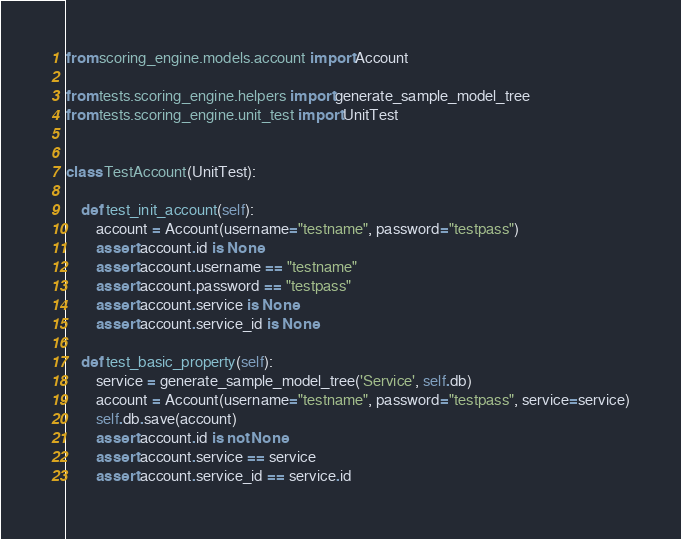<code> <loc_0><loc_0><loc_500><loc_500><_Python_>from scoring_engine.models.account import Account

from tests.scoring_engine.helpers import generate_sample_model_tree
from tests.scoring_engine.unit_test import UnitTest


class TestAccount(UnitTest):

    def test_init_account(self):
        account = Account(username="testname", password="testpass")
        assert account.id is None
        assert account.username == "testname"
        assert account.password == "testpass"
        assert account.service is None
        assert account.service_id is None

    def test_basic_property(self):
        service = generate_sample_model_tree('Service', self.db)
        account = Account(username="testname", password="testpass", service=service)
        self.db.save(account)
        assert account.id is not None
        assert account.service == service
        assert account.service_id == service.id
</code> 